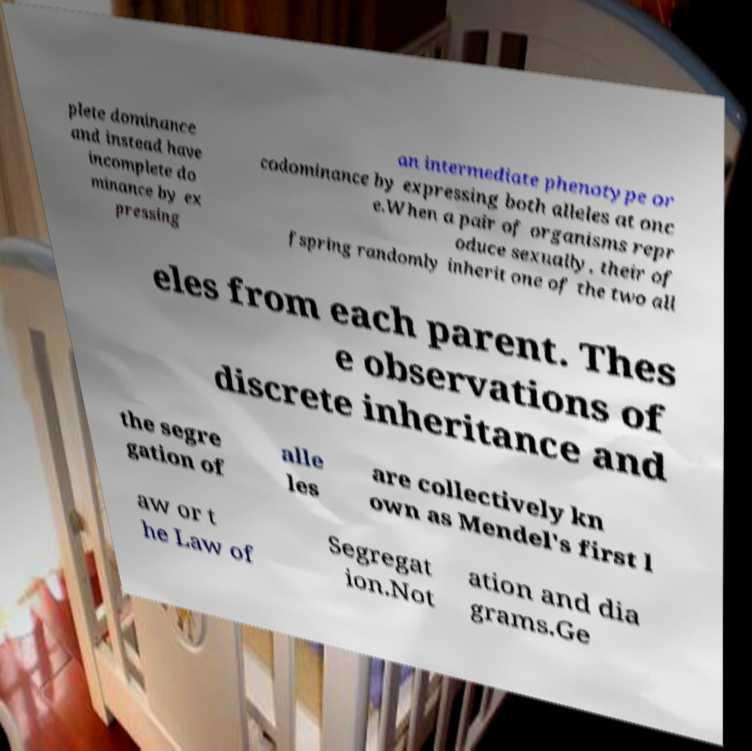Can you read and provide the text displayed in the image?This photo seems to have some interesting text. Can you extract and type it out for me? plete dominance and instead have incomplete do minance by ex pressing an intermediate phenotype or codominance by expressing both alleles at onc e.When a pair of organisms repr oduce sexually, their of fspring randomly inherit one of the two all eles from each parent. Thes e observations of discrete inheritance and the segre gation of alle les are collectively kn own as Mendel's first l aw or t he Law of Segregat ion.Not ation and dia grams.Ge 